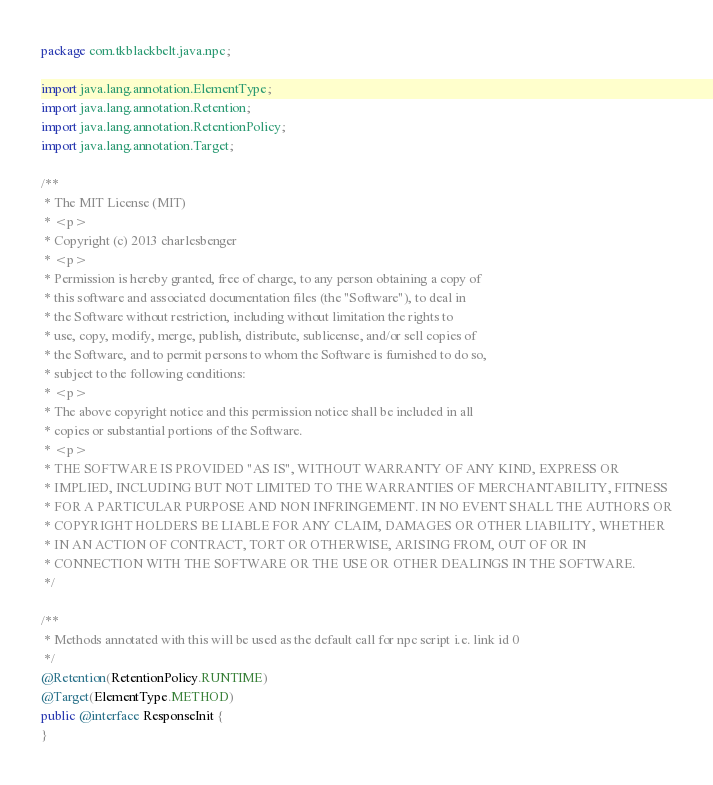<code> <loc_0><loc_0><loc_500><loc_500><_Java_>package com.tkblackbelt.java.npc;

import java.lang.annotation.ElementType;
import java.lang.annotation.Retention;
import java.lang.annotation.RetentionPolicy;
import java.lang.annotation.Target;

/**
 * The MIT License (MIT)
 * <p>
 * Copyright (c) 2013 charlesbenger
 * <p>
 * Permission is hereby granted, free of charge, to any person obtaining a copy of
 * this software and associated documentation files (the "Software"), to deal in
 * the Software without restriction, including without limitation the rights to
 * use, copy, modify, merge, publish, distribute, sublicense, and/or sell copies of
 * the Software, and to permit persons to whom the Software is furnished to do so,
 * subject to the following conditions:
 * <p>
 * The above copyright notice and this permission notice shall be included in all
 * copies or substantial portions of the Software.
 * <p>
 * THE SOFTWARE IS PROVIDED "AS IS", WITHOUT WARRANTY OF ANY KIND, EXPRESS OR
 * IMPLIED, INCLUDING BUT NOT LIMITED TO THE WARRANTIES OF MERCHANTABILITY, FITNESS
 * FOR A PARTICULAR PURPOSE AND NON INFRINGEMENT. IN NO EVENT SHALL THE AUTHORS OR
 * COPYRIGHT HOLDERS BE LIABLE FOR ANY CLAIM, DAMAGES OR OTHER LIABILITY, WHETHER
 * IN AN ACTION OF CONTRACT, TORT OR OTHERWISE, ARISING FROM, OUT OF OR IN
 * CONNECTION WITH THE SOFTWARE OR THE USE OR OTHER DEALINGS IN THE SOFTWARE.
 */

/**
 * Methods annotated with this will be used as the default call for npc script i.e. link id 0
 */
@Retention(RetentionPolicy.RUNTIME)
@Target(ElementType.METHOD)
public @interface ResponseInit {
}
</code> 